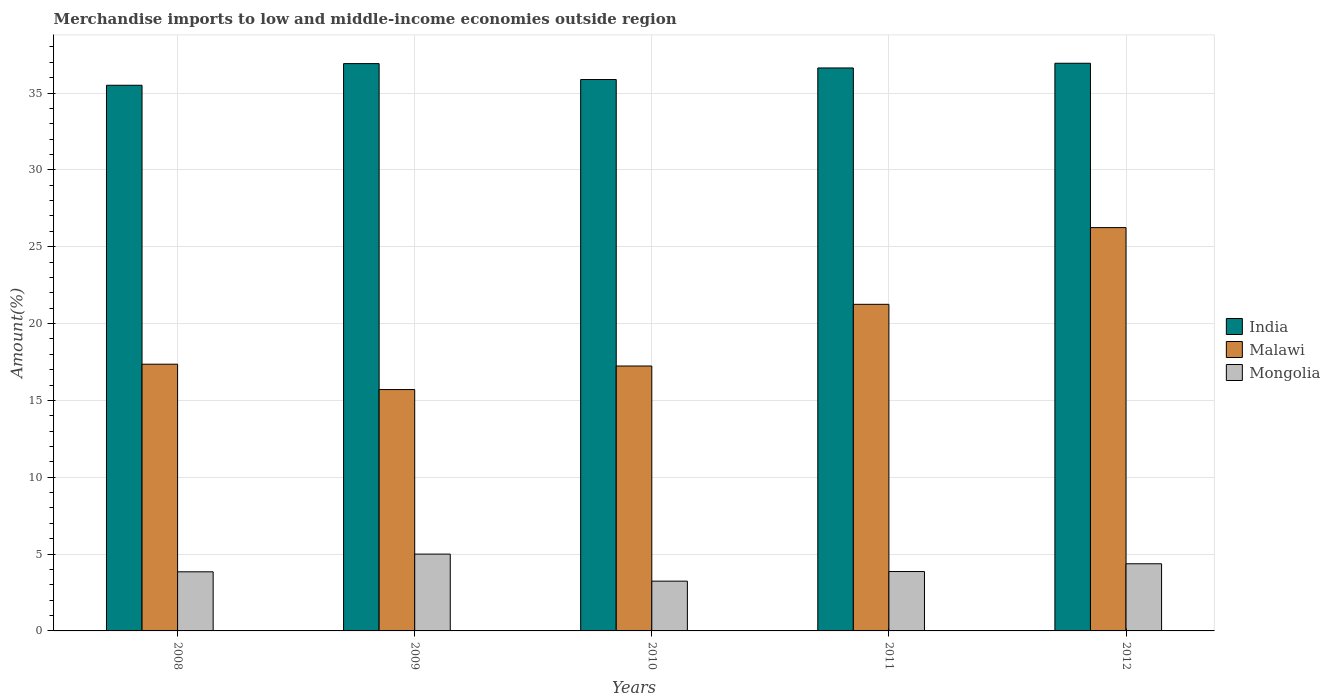How many different coloured bars are there?
Offer a terse response. 3. How many groups of bars are there?
Give a very brief answer. 5. Are the number of bars per tick equal to the number of legend labels?
Keep it short and to the point. Yes. How many bars are there on the 1st tick from the right?
Keep it short and to the point. 3. What is the label of the 1st group of bars from the left?
Offer a terse response. 2008. What is the percentage of amount earned from merchandise imports in Malawi in 2009?
Keep it short and to the point. 15.7. Across all years, what is the maximum percentage of amount earned from merchandise imports in Malawi?
Your answer should be compact. 26.24. Across all years, what is the minimum percentage of amount earned from merchandise imports in Malawi?
Offer a terse response. 15.7. What is the total percentage of amount earned from merchandise imports in Mongolia in the graph?
Offer a very short reply. 20.32. What is the difference between the percentage of amount earned from merchandise imports in Mongolia in 2011 and that in 2012?
Provide a short and direct response. -0.51. What is the difference between the percentage of amount earned from merchandise imports in Malawi in 2011 and the percentage of amount earned from merchandise imports in Mongolia in 2009?
Ensure brevity in your answer.  16.25. What is the average percentage of amount earned from merchandise imports in India per year?
Make the answer very short. 36.37. In the year 2009, what is the difference between the percentage of amount earned from merchandise imports in India and percentage of amount earned from merchandise imports in Malawi?
Provide a short and direct response. 21.21. In how many years, is the percentage of amount earned from merchandise imports in Malawi greater than 26 %?
Your answer should be very brief. 1. What is the ratio of the percentage of amount earned from merchandise imports in Mongolia in 2010 to that in 2012?
Your answer should be compact. 0.74. Is the percentage of amount earned from merchandise imports in Mongolia in 2010 less than that in 2012?
Your answer should be compact. Yes. What is the difference between the highest and the second highest percentage of amount earned from merchandise imports in India?
Give a very brief answer. 0.02. What is the difference between the highest and the lowest percentage of amount earned from merchandise imports in Mongolia?
Your answer should be compact. 1.76. What does the 3rd bar from the left in 2008 represents?
Offer a very short reply. Mongolia. What does the 1st bar from the right in 2008 represents?
Your answer should be compact. Mongolia. Are all the bars in the graph horizontal?
Ensure brevity in your answer.  No. What is the difference between two consecutive major ticks on the Y-axis?
Offer a very short reply. 5. Does the graph contain any zero values?
Ensure brevity in your answer.  No. How are the legend labels stacked?
Make the answer very short. Vertical. What is the title of the graph?
Give a very brief answer. Merchandise imports to low and middle-income economies outside region. What is the label or title of the Y-axis?
Your answer should be very brief. Amount(%). What is the Amount(%) of India in 2008?
Make the answer very short. 35.51. What is the Amount(%) in Malawi in 2008?
Your answer should be compact. 17.36. What is the Amount(%) in Mongolia in 2008?
Your response must be concise. 3.85. What is the Amount(%) of India in 2009?
Your answer should be compact. 36.91. What is the Amount(%) of Malawi in 2009?
Your answer should be compact. 15.7. What is the Amount(%) of Mongolia in 2009?
Give a very brief answer. 5. What is the Amount(%) of India in 2010?
Your answer should be compact. 35.88. What is the Amount(%) in Malawi in 2010?
Your response must be concise. 17.24. What is the Amount(%) of Mongolia in 2010?
Keep it short and to the point. 3.24. What is the Amount(%) in India in 2011?
Give a very brief answer. 36.63. What is the Amount(%) of Malawi in 2011?
Your answer should be very brief. 21.25. What is the Amount(%) of Mongolia in 2011?
Your response must be concise. 3.86. What is the Amount(%) of India in 2012?
Offer a terse response. 36.94. What is the Amount(%) in Malawi in 2012?
Provide a short and direct response. 26.24. What is the Amount(%) of Mongolia in 2012?
Make the answer very short. 4.37. Across all years, what is the maximum Amount(%) in India?
Offer a very short reply. 36.94. Across all years, what is the maximum Amount(%) in Malawi?
Offer a very short reply. 26.24. Across all years, what is the maximum Amount(%) of Mongolia?
Make the answer very short. 5. Across all years, what is the minimum Amount(%) of India?
Make the answer very short. 35.51. Across all years, what is the minimum Amount(%) of Malawi?
Your answer should be compact. 15.7. Across all years, what is the minimum Amount(%) in Mongolia?
Keep it short and to the point. 3.24. What is the total Amount(%) of India in the graph?
Ensure brevity in your answer.  181.86. What is the total Amount(%) in Malawi in the graph?
Ensure brevity in your answer.  97.79. What is the total Amount(%) of Mongolia in the graph?
Your response must be concise. 20.32. What is the difference between the Amount(%) of India in 2008 and that in 2009?
Keep it short and to the point. -1.41. What is the difference between the Amount(%) in Malawi in 2008 and that in 2009?
Offer a very short reply. 1.65. What is the difference between the Amount(%) in Mongolia in 2008 and that in 2009?
Give a very brief answer. -1.15. What is the difference between the Amount(%) of India in 2008 and that in 2010?
Your answer should be compact. -0.37. What is the difference between the Amount(%) of Malawi in 2008 and that in 2010?
Keep it short and to the point. 0.12. What is the difference between the Amount(%) in Mongolia in 2008 and that in 2010?
Offer a terse response. 0.61. What is the difference between the Amount(%) of India in 2008 and that in 2011?
Your response must be concise. -1.12. What is the difference between the Amount(%) in Malawi in 2008 and that in 2011?
Offer a very short reply. -3.9. What is the difference between the Amount(%) in Mongolia in 2008 and that in 2011?
Provide a short and direct response. -0.02. What is the difference between the Amount(%) of India in 2008 and that in 2012?
Provide a succinct answer. -1.43. What is the difference between the Amount(%) of Malawi in 2008 and that in 2012?
Provide a short and direct response. -8.89. What is the difference between the Amount(%) in Mongolia in 2008 and that in 2012?
Provide a succinct answer. -0.52. What is the difference between the Amount(%) of India in 2009 and that in 2010?
Give a very brief answer. 1.03. What is the difference between the Amount(%) in Malawi in 2009 and that in 2010?
Your response must be concise. -1.53. What is the difference between the Amount(%) in Mongolia in 2009 and that in 2010?
Provide a short and direct response. 1.76. What is the difference between the Amount(%) of India in 2009 and that in 2011?
Ensure brevity in your answer.  0.28. What is the difference between the Amount(%) in Malawi in 2009 and that in 2011?
Provide a succinct answer. -5.55. What is the difference between the Amount(%) in Mongolia in 2009 and that in 2011?
Your answer should be compact. 1.13. What is the difference between the Amount(%) of India in 2009 and that in 2012?
Your answer should be very brief. -0.02. What is the difference between the Amount(%) in Malawi in 2009 and that in 2012?
Provide a short and direct response. -10.54. What is the difference between the Amount(%) in Mongolia in 2009 and that in 2012?
Provide a succinct answer. 0.63. What is the difference between the Amount(%) in India in 2010 and that in 2011?
Your response must be concise. -0.75. What is the difference between the Amount(%) of Malawi in 2010 and that in 2011?
Ensure brevity in your answer.  -4.01. What is the difference between the Amount(%) of Mongolia in 2010 and that in 2011?
Offer a terse response. -0.62. What is the difference between the Amount(%) of India in 2010 and that in 2012?
Ensure brevity in your answer.  -1.06. What is the difference between the Amount(%) in Malawi in 2010 and that in 2012?
Keep it short and to the point. -9.01. What is the difference between the Amount(%) of Mongolia in 2010 and that in 2012?
Ensure brevity in your answer.  -1.13. What is the difference between the Amount(%) of India in 2011 and that in 2012?
Your answer should be very brief. -0.31. What is the difference between the Amount(%) of Malawi in 2011 and that in 2012?
Offer a terse response. -4.99. What is the difference between the Amount(%) in Mongolia in 2011 and that in 2012?
Give a very brief answer. -0.51. What is the difference between the Amount(%) of India in 2008 and the Amount(%) of Malawi in 2009?
Provide a short and direct response. 19.8. What is the difference between the Amount(%) in India in 2008 and the Amount(%) in Mongolia in 2009?
Ensure brevity in your answer.  30.51. What is the difference between the Amount(%) of Malawi in 2008 and the Amount(%) of Mongolia in 2009?
Provide a succinct answer. 12.36. What is the difference between the Amount(%) of India in 2008 and the Amount(%) of Malawi in 2010?
Give a very brief answer. 18.27. What is the difference between the Amount(%) in India in 2008 and the Amount(%) in Mongolia in 2010?
Ensure brevity in your answer.  32.27. What is the difference between the Amount(%) in Malawi in 2008 and the Amount(%) in Mongolia in 2010?
Give a very brief answer. 14.12. What is the difference between the Amount(%) in India in 2008 and the Amount(%) in Malawi in 2011?
Provide a short and direct response. 14.25. What is the difference between the Amount(%) of India in 2008 and the Amount(%) of Mongolia in 2011?
Keep it short and to the point. 31.64. What is the difference between the Amount(%) of Malawi in 2008 and the Amount(%) of Mongolia in 2011?
Keep it short and to the point. 13.49. What is the difference between the Amount(%) in India in 2008 and the Amount(%) in Malawi in 2012?
Ensure brevity in your answer.  9.26. What is the difference between the Amount(%) of India in 2008 and the Amount(%) of Mongolia in 2012?
Make the answer very short. 31.14. What is the difference between the Amount(%) in Malawi in 2008 and the Amount(%) in Mongolia in 2012?
Provide a short and direct response. 12.99. What is the difference between the Amount(%) of India in 2009 and the Amount(%) of Malawi in 2010?
Offer a very short reply. 19.68. What is the difference between the Amount(%) in India in 2009 and the Amount(%) in Mongolia in 2010?
Provide a succinct answer. 33.67. What is the difference between the Amount(%) of Malawi in 2009 and the Amount(%) of Mongolia in 2010?
Your answer should be compact. 12.47. What is the difference between the Amount(%) in India in 2009 and the Amount(%) in Malawi in 2011?
Ensure brevity in your answer.  15.66. What is the difference between the Amount(%) of India in 2009 and the Amount(%) of Mongolia in 2011?
Your answer should be compact. 33.05. What is the difference between the Amount(%) of Malawi in 2009 and the Amount(%) of Mongolia in 2011?
Offer a very short reply. 11.84. What is the difference between the Amount(%) of India in 2009 and the Amount(%) of Malawi in 2012?
Offer a very short reply. 10.67. What is the difference between the Amount(%) of India in 2009 and the Amount(%) of Mongolia in 2012?
Offer a very short reply. 32.54. What is the difference between the Amount(%) of Malawi in 2009 and the Amount(%) of Mongolia in 2012?
Your answer should be very brief. 11.34. What is the difference between the Amount(%) of India in 2010 and the Amount(%) of Malawi in 2011?
Offer a terse response. 14.63. What is the difference between the Amount(%) of India in 2010 and the Amount(%) of Mongolia in 2011?
Offer a terse response. 32.02. What is the difference between the Amount(%) of Malawi in 2010 and the Amount(%) of Mongolia in 2011?
Provide a short and direct response. 13.37. What is the difference between the Amount(%) of India in 2010 and the Amount(%) of Malawi in 2012?
Your answer should be very brief. 9.64. What is the difference between the Amount(%) in India in 2010 and the Amount(%) in Mongolia in 2012?
Offer a terse response. 31.51. What is the difference between the Amount(%) in Malawi in 2010 and the Amount(%) in Mongolia in 2012?
Offer a very short reply. 12.87. What is the difference between the Amount(%) in India in 2011 and the Amount(%) in Malawi in 2012?
Provide a short and direct response. 10.39. What is the difference between the Amount(%) in India in 2011 and the Amount(%) in Mongolia in 2012?
Provide a succinct answer. 32.26. What is the difference between the Amount(%) of Malawi in 2011 and the Amount(%) of Mongolia in 2012?
Your answer should be very brief. 16.88. What is the average Amount(%) of India per year?
Your answer should be very brief. 36.37. What is the average Amount(%) of Malawi per year?
Your answer should be compact. 19.56. What is the average Amount(%) of Mongolia per year?
Make the answer very short. 4.06. In the year 2008, what is the difference between the Amount(%) in India and Amount(%) in Malawi?
Offer a very short reply. 18.15. In the year 2008, what is the difference between the Amount(%) of India and Amount(%) of Mongolia?
Your answer should be very brief. 31.66. In the year 2008, what is the difference between the Amount(%) in Malawi and Amount(%) in Mongolia?
Provide a succinct answer. 13.51. In the year 2009, what is the difference between the Amount(%) of India and Amount(%) of Malawi?
Make the answer very short. 21.21. In the year 2009, what is the difference between the Amount(%) of India and Amount(%) of Mongolia?
Give a very brief answer. 31.91. In the year 2009, what is the difference between the Amount(%) in Malawi and Amount(%) in Mongolia?
Ensure brevity in your answer.  10.71. In the year 2010, what is the difference between the Amount(%) in India and Amount(%) in Malawi?
Your response must be concise. 18.64. In the year 2010, what is the difference between the Amount(%) of India and Amount(%) of Mongolia?
Make the answer very short. 32.64. In the year 2010, what is the difference between the Amount(%) in Malawi and Amount(%) in Mongolia?
Keep it short and to the point. 14. In the year 2011, what is the difference between the Amount(%) in India and Amount(%) in Malawi?
Ensure brevity in your answer.  15.38. In the year 2011, what is the difference between the Amount(%) in India and Amount(%) in Mongolia?
Offer a terse response. 32.77. In the year 2011, what is the difference between the Amount(%) of Malawi and Amount(%) of Mongolia?
Your answer should be compact. 17.39. In the year 2012, what is the difference between the Amount(%) of India and Amount(%) of Malawi?
Keep it short and to the point. 10.69. In the year 2012, what is the difference between the Amount(%) in India and Amount(%) in Mongolia?
Your answer should be very brief. 32.57. In the year 2012, what is the difference between the Amount(%) of Malawi and Amount(%) of Mongolia?
Your answer should be compact. 21.87. What is the ratio of the Amount(%) in India in 2008 to that in 2009?
Your answer should be very brief. 0.96. What is the ratio of the Amount(%) of Malawi in 2008 to that in 2009?
Your answer should be compact. 1.11. What is the ratio of the Amount(%) in Mongolia in 2008 to that in 2009?
Give a very brief answer. 0.77. What is the ratio of the Amount(%) of India in 2008 to that in 2010?
Your answer should be compact. 0.99. What is the ratio of the Amount(%) in Mongolia in 2008 to that in 2010?
Provide a succinct answer. 1.19. What is the ratio of the Amount(%) in India in 2008 to that in 2011?
Ensure brevity in your answer.  0.97. What is the ratio of the Amount(%) in Malawi in 2008 to that in 2011?
Offer a very short reply. 0.82. What is the ratio of the Amount(%) of India in 2008 to that in 2012?
Your answer should be very brief. 0.96. What is the ratio of the Amount(%) of Malawi in 2008 to that in 2012?
Give a very brief answer. 0.66. What is the ratio of the Amount(%) in Mongolia in 2008 to that in 2012?
Offer a very short reply. 0.88. What is the ratio of the Amount(%) of India in 2009 to that in 2010?
Ensure brevity in your answer.  1.03. What is the ratio of the Amount(%) in Malawi in 2009 to that in 2010?
Your response must be concise. 0.91. What is the ratio of the Amount(%) of Mongolia in 2009 to that in 2010?
Your answer should be very brief. 1.54. What is the ratio of the Amount(%) of India in 2009 to that in 2011?
Provide a short and direct response. 1.01. What is the ratio of the Amount(%) of Malawi in 2009 to that in 2011?
Give a very brief answer. 0.74. What is the ratio of the Amount(%) in Mongolia in 2009 to that in 2011?
Provide a short and direct response. 1.29. What is the ratio of the Amount(%) of India in 2009 to that in 2012?
Make the answer very short. 1. What is the ratio of the Amount(%) of Malawi in 2009 to that in 2012?
Keep it short and to the point. 0.6. What is the ratio of the Amount(%) in Mongolia in 2009 to that in 2012?
Give a very brief answer. 1.14. What is the ratio of the Amount(%) in India in 2010 to that in 2011?
Your response must be concise. 0.98. What is the ratio of the Amount(%) in Malawi in 2010 to that in 2011?
Your response must be concise. 0.81. What is the ratio of the Amount(%) in Mongolia in 2010 to that in 2011?
Offer a terse response. 0.84. What is the ratio of the Amount(%) of India in 2010 to that in 2012?
Offer a very short reply. 0.97. What is the ratio of the Amount(%) in Malawi in 2010 to that in 2012?
Your response must be concise. 0.66. What is the ratio of the Amount(%) of Mongolia in 2010 to that in 2012?
Provide a succinct answer. 0.74. What is the ratio of the Amount(%) in India in 2011 to that in 2012?
Ensure brevity in your answer.  0.99. What is the ratio of the Amount(%) in Malawi in 2011 to that in 2012?
Offer a very short reply. 0.81. What is the ratio of the Amount(%) in Mongolia in 2011 to that in 2012?
Offer a terse response. 0.88. What is the difference between the highest and the second highest Amount(%) of India?
Your answer should be compact. 0.02. What is the difference between the highest and the second highest Amount(%) of Malawi?
Your response must be concise. 4.99. What is the difference between the highest and the second highest Amount(%) in Mongolia?
Your answer should be compact. 0.63. What is the difference between the highest and the lowest Amount(%) in India?
Your answer should be compact. 1.43. What is the difference between the highest and the lowest Amount(%) of Malawi?
Your response must be concise. 10.54. What is the difference between the highest and the lowest Amount(%) in Mongolia?
Keep it short and to the point. 1.76. 